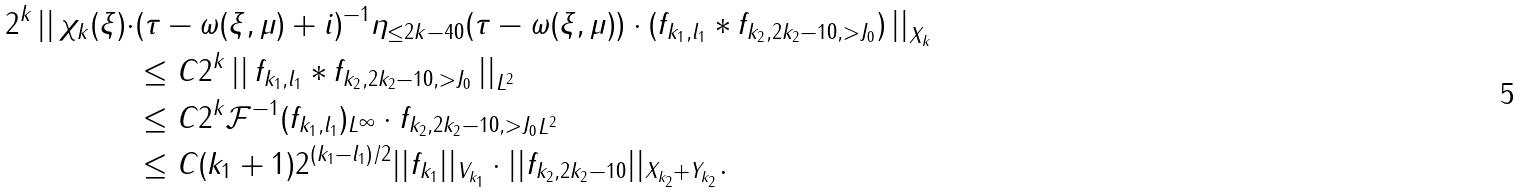<formula> <loc_0><loc_0><loc_500><loc_500>2 ^ { k } \left | \right | \chi _ { k } ( \xi ) \cdot & ( \tau - \omega ( \xi , \mu ) + i ) ^ { - 1 } \eta _ { \leq 2 k - 4 0 } ( \tau - \omega ( \xi , \mu ) ) \cdot ( f _ { k _ { 1 } , l _ { 1 } } \ast f _ { k _ { 2 } , 2 k _ { 2 } - 1 0 , > J _ { 0 } } ) \left | \right | _ { X _ { k } } \\ & \leq C 2 ^ { k } \left | \right | f _ { k _ { 1 } , l _ { 1 } } \ast f _ { k _ { 2 } , 2 k _ { 2 } - 1 0 , > J _ { 0 } } \left | \right | _ { L ^ { 2 } } \\ & \leq C 2 ^ { k } \| \mathcal { F } ^ { - 1 } ( f _ { k _ { 1 } , l _ { 1 } } ) \| _ { L ^ { \infty } } \cdot \| f _ { k _ { 2 } , 2 k _ { 2 } - 1 0 , > J _ { 0 } } \| _ { L ^ { 2 } } \\ & \leq C ( k _ { 1 } + 1 ) 2 ^ { ( k _ { 1 } - l _ { 1 } ) / 2 } | | f _ { k _ { 1 } } | | _ { V _ { k _ { 1 } } } \cdot | | f _ { k _ { 2 } , 2 k _ { 2 } - 1 0 } | | _ { X _ { k _ { 2 } } + Y _ { k _ { 2 } } } .</formula> 